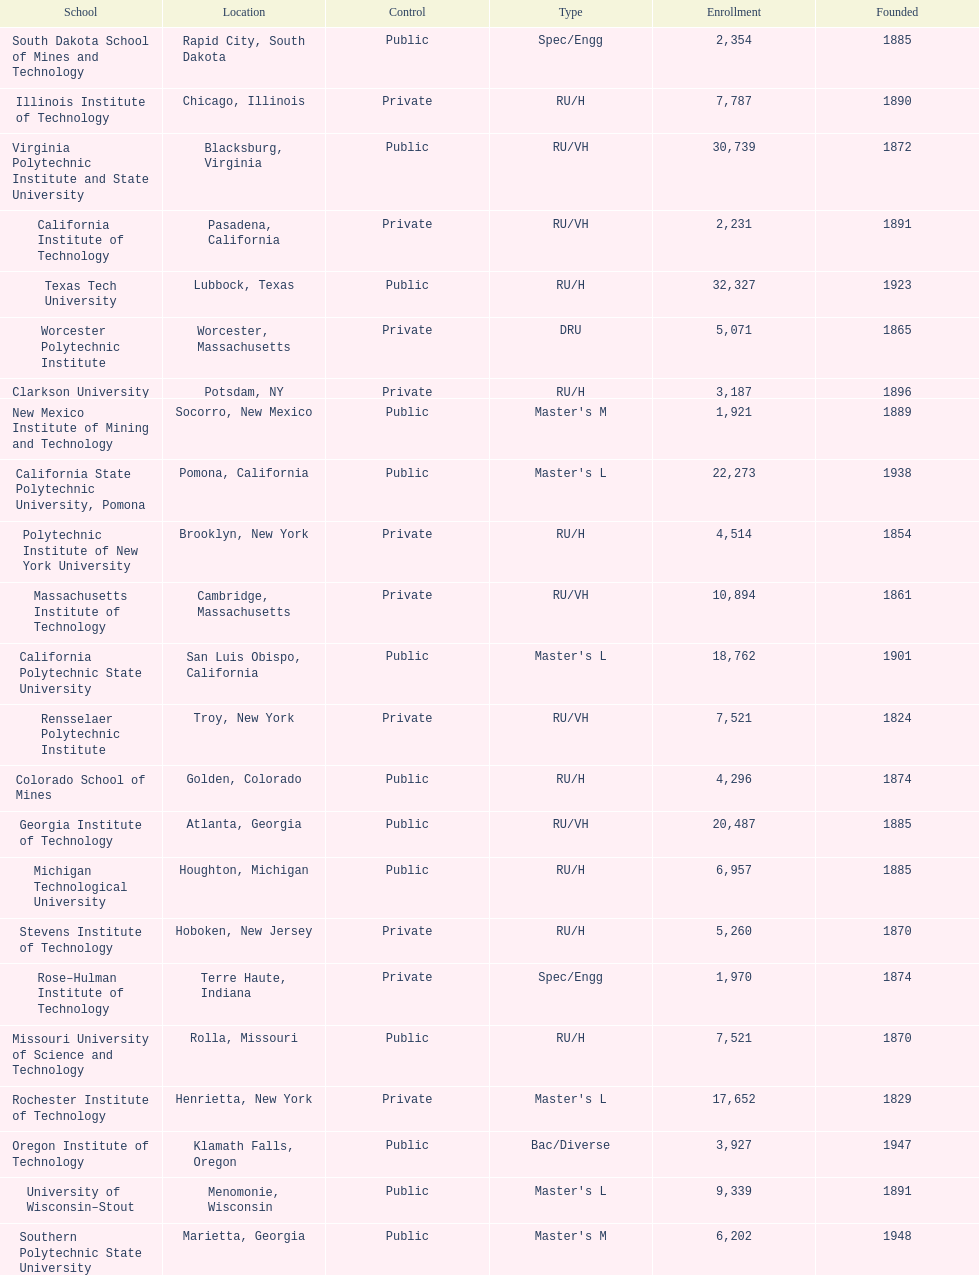Parse the table in full. {'header': ['School', 'Location', 'Control', 'Type', 'Enrollment', 'Founded'], 'rows': [['South Dakota School of Mines and Technology', 'Rapid City, South Dakota', 'Public', 'Spec/Engg', '2,354', '1885'], ['Illinois Institute of Technology', 'Chicago, Illinois', 'Private', 'RU/H', '7,787', '1890'], ['Virginia Polytechnic Institute and State University', 'Blacksburg, Virginia', 'Public', 'RU/VH', '30,739', '1872'], ['California Institute of Technology', 'Pasadena, California', 'Private', 'RU/VH', '2,231', '1891'], ['Texas Tech University', 'Lubbock, Texas', 'Public', 'RU/H', '32,327', '1923'], ['Worcester Polytechnic Institute', 'Worcester, Massachusetts', 'Private', 'DRU', '5,071', '1865'], ['Clarkson University', 'Potsdam, NY', 'Private', 'RU/H', '3,187', '1896'], ['New Mexico Institute of Mining and Technology', 'Socorro, New Mexico', 'Public', "Master's M", '1,921', '1889'], ['California State Polytechnic University, Pomona', 'Pomona, California', 'Public', "Master's L", '22,273', '1938'], ['Polytechnic Institute of New York University', 'Brooklyn, New York', 'Private', 'RU/H', '4,514', '1854'], ['Massachusetts Institute of Technology', 'Cambridge, Massachusetts', 'Private', 'RU/VH', '10,894', '1861'], ['California Polytechnic State University', 'San Luis Obispo, California', 'Public', "Master's L", '18,762', '1901'], ['Rensselaer Polytechnic Institute', 'Troy, New York', 'Private', 'RU/VH', '7,521', '1824'], ['Colorado School of Mines', 'Golden, Colorado', 'Public', 'RU/H', '4,296', '1874'], ['Georgia Institute of Technology', 'Atlanta, Georgia', 'Public', 'RU/VH', '20,487', '1885'], ['Michigan Technological University', 'Houghton, Michigan', 'Public', 'RU/H', '6,957', '1885'], ['Stevens Institute of Technology', 'Hoboken, New Jersey', 'Private', 'RU/H', '5,260', '1870'], ['Rose–Hulman Institute of Technology', 'Terre Haute, Indiana', 'Private', 'Spec/Engg', '1,970', '1874'], ['Missouri University of Science and Technology', 'Rolla, Missouri', 'Public', 'RU/H', '7,521', '1870'], ['Rochester Institute of Technology', 'Henrietta, New York', 'Private', "Master's L", '17,652', '1829'], ['Oregon Institute of Technology', 'Klamath Falls, Oregon', 'Public', 'Bac/Diverse', '3,927', '1947'], ['University of Wisconsin–Stout', 'Menomonie, Wisconsin', 'Public', "Master's L", '9,339', '1891'], ['Southern Polytechnic State University', 'Marietta, Georgia', 'Public', "Master's M", '6,202', '1948'], ['Florida Institute of Technology', 'Melbourne, Florida', 'Private', 'DRU', '8,985', '1958'], ['Colorado Technical University', 'Colorado Springs, Colorado', 'Private', 'DRU', '30,020', '1965'], ['Montana Tech of the University of Montana', 'Butte, Montana', 'Public', 'Bac/Diverse', '2,694', '1900'], ['Air Force Institute of Technology', 'Wright-Patterson AFB, Ohio', 'Public', 'DRU', '719', '1919'], ['New Jersey Institute of Technology', 'Newark, New Jersey', 'Private', 'RU/H', '9,558', '1881']]} What is the total number of schools listed in the table? 28. 